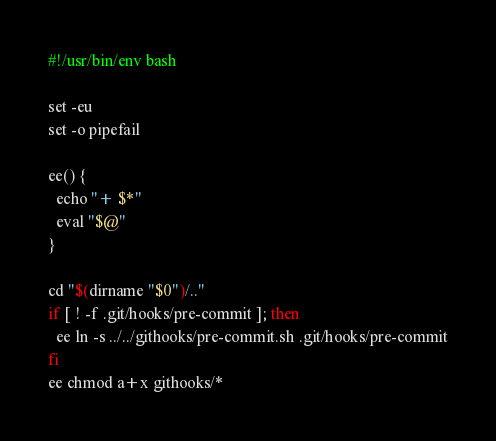<code> <loc_0><loc_0><loc_500><loc_500><_Bash_>#!/usr/bin/env bash

set -eu
set -o pipefail

ee() {
  echo "+ $*"
  eval "$@"
}

cd "$(dirname "$0")/.."
if [ ! -f .git/hooks/pre-commit ]; then
  ee ln -s ../../githooks/pre-commit.sh .git/hooks/pre-commit
fi
ee chmod a+x githooks/*
</code> 